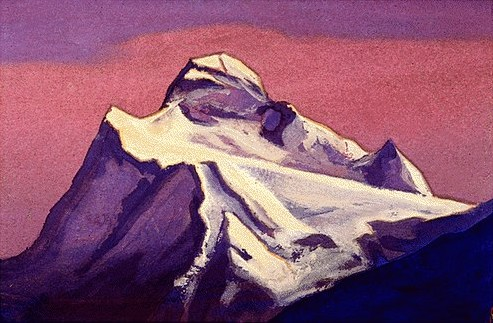Analyze the image in a comprehensive and detailed manner. The depicted image portrays a mountain peak using an impressionist technique, characterized by broad, loose brushstrokes that blend vibrant colors directly on the canvas. The artist has chosen a palette of purples and pinks to depict the sky, which contrasts strikingly with the whites and grays of the snow-laden mountain. The play of color not only captures the natural beauty of the landscape but also conveys a mood of serene majesty. The distant perspective and shadowing effects further give the mountain a monumental and somewhat ethereal presence, suggesting possibly deeper themes like the enduring power of nature or the sublime. 